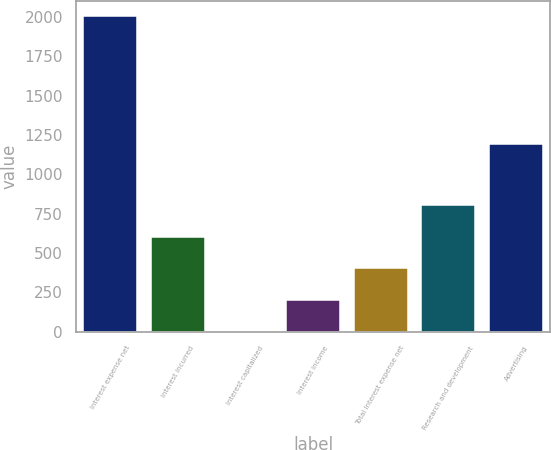Convert chart to OTSL. <chart><loc_0><loc_0><loc_500><loc_500><bar_chart><fcel>Interest expense net<fcel>Interest incurred<fcel>Interest capitalized<fcel>Interest income<fcel>Total Interest expense net<fcel>Research and development<fcel>Advertising<nl><fcel>2005<fcel>603.25<fcel>2.5<fcel>202.75<fcel>403<fcel>803.5<fcel>1193.6<nl></chart> 